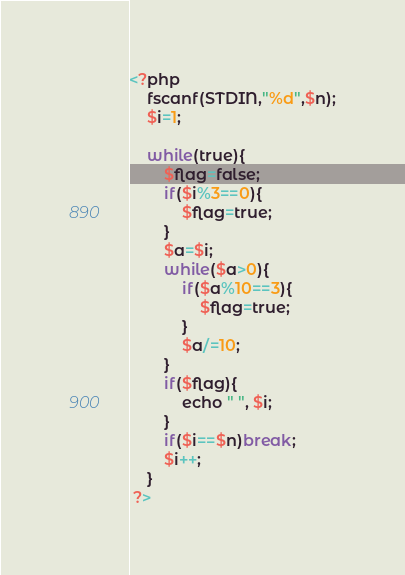Convert code to text. <code><loc_0><loc_0><loc_500><loc_500><_Python_><?php
    fscanf(STDIN,"%d",$n);
    $i=1;

    while(true){
        $flag=false;
        if($i%3==0){
            $flag=true;
        }
        $a=$i;
        while($a>0){
            if($a%10==3){
                $flag=true;
            }
            $a/=10;
        }
        if($flag){
            echo " ", $i;
        }
        if($i==$n)break;
        $i++;
    }
 ?></code> 